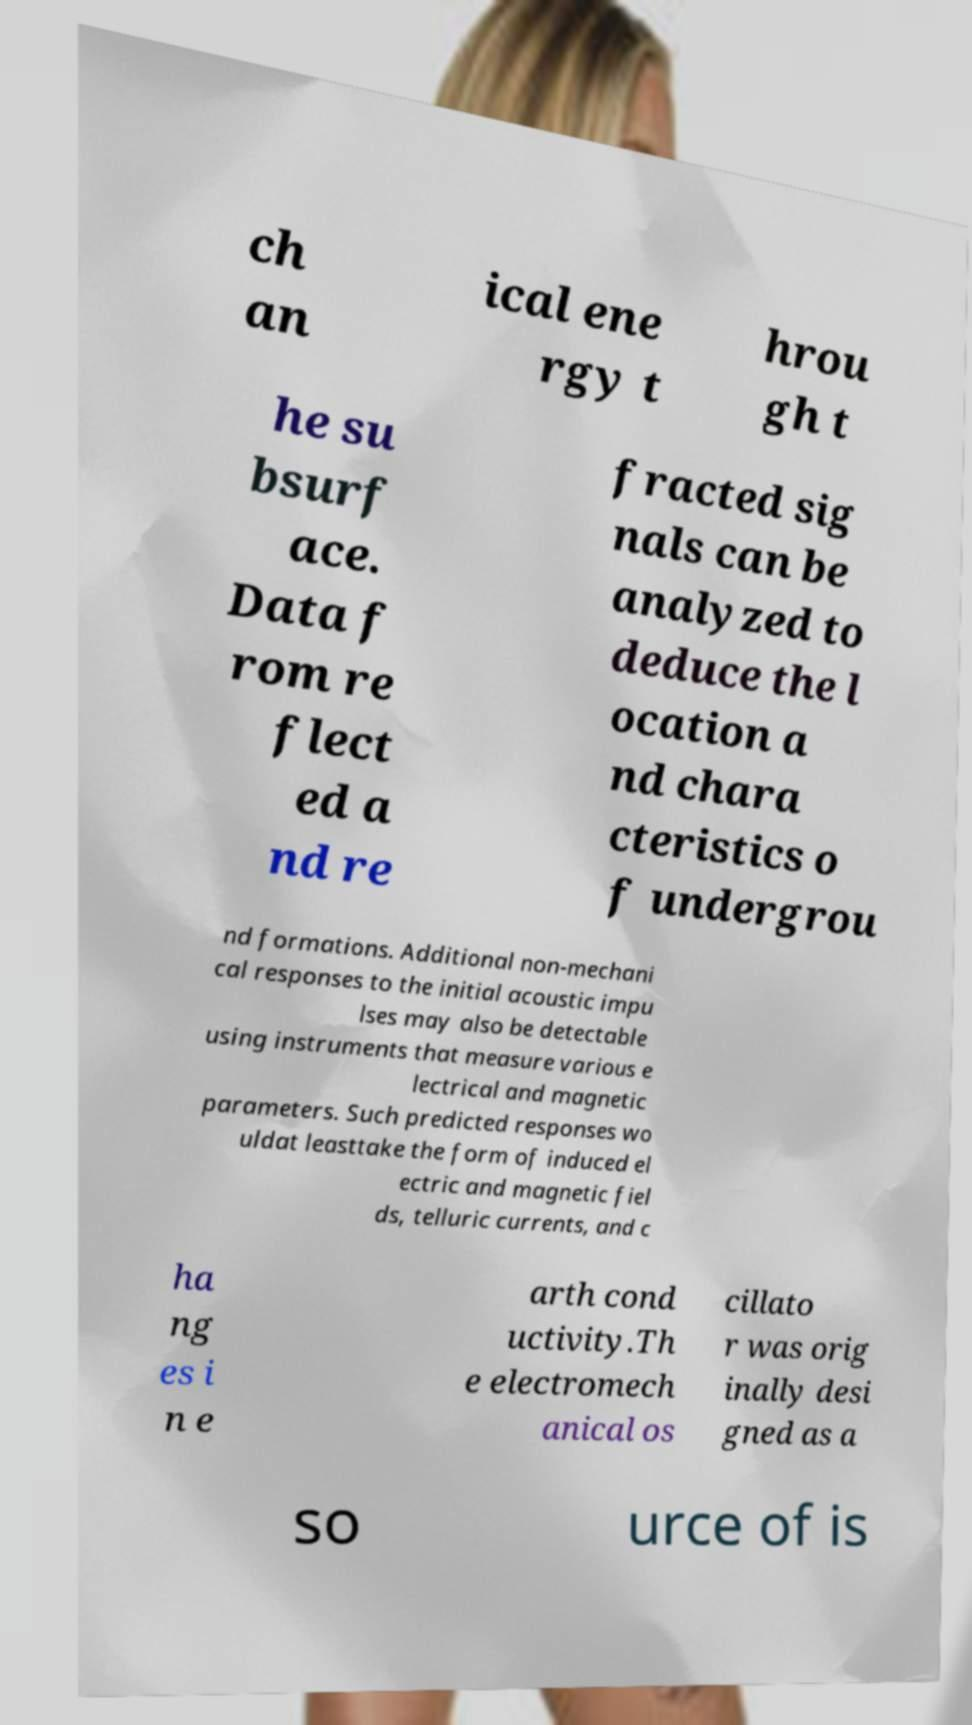Can you read and provide the text displayed in the image?This photo seems to have some interesting text. Can you extract and type it out for me? ch an ical ene rgy t hrou gh t he su bsurf ace. Data f rom re flect ed a nd re fracted sig nals can be analyzed to deduce the l ocation a nd chara cteristics o f undergrou nd formations. Additional non-mechani cal responses to the initial acoustic impu lses may also be detectable using instruments that measure various e lectrical and magnetic parameters. Such predicted responses wo uldat leasttake the form of induced el ectric and magnetic fiel ds, telluric currents, and c ha ng es i n e arth cond uctivity.Th e electromech anical os cillato r was orig inally desi gned as a so urce of is 